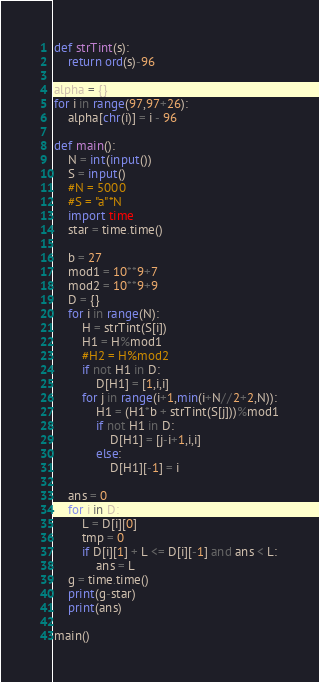Convert code to text. <code><loc_0><loc_0><loc_500><loc_500><_Python_>def strTint(s):
    return ord(s)-96

alpha = {}
for i in range(97,97+26):
    alpha[chr(i)] = i - 96

def main():
    N = int(input())
    S = input()
    #N = 5000
    #S = "a"*N
    import time
    star = time.time()
    
    b = 27
    mod1 = 10**9+7
    mod2 = 10**9+9
    D = {}
    for i in range(N):
        H = strTint(S[i])
        H1 = H%mod1
        #H2 = H%mod2
        if not H1 in D:
            D[H1] = [1,i,i]
        for j in range(i+1,min(i+N//2+2,N)):
            H1 = (H1*b + strTint(S[j]))%mod1
            if not H1 in D:
                D[H1] = [j-i+1,i,i]
            else:
                D[H1][-1] = i
    
    ans = 0
    for i in D:
        L = D[i][0]
        tmp = 0
        if D[i][1] + L <= D[i][-1] and ans < L:
            ans = L
    g = time.time()
    print(g-star)
    print(ans)
    
main()</code> 